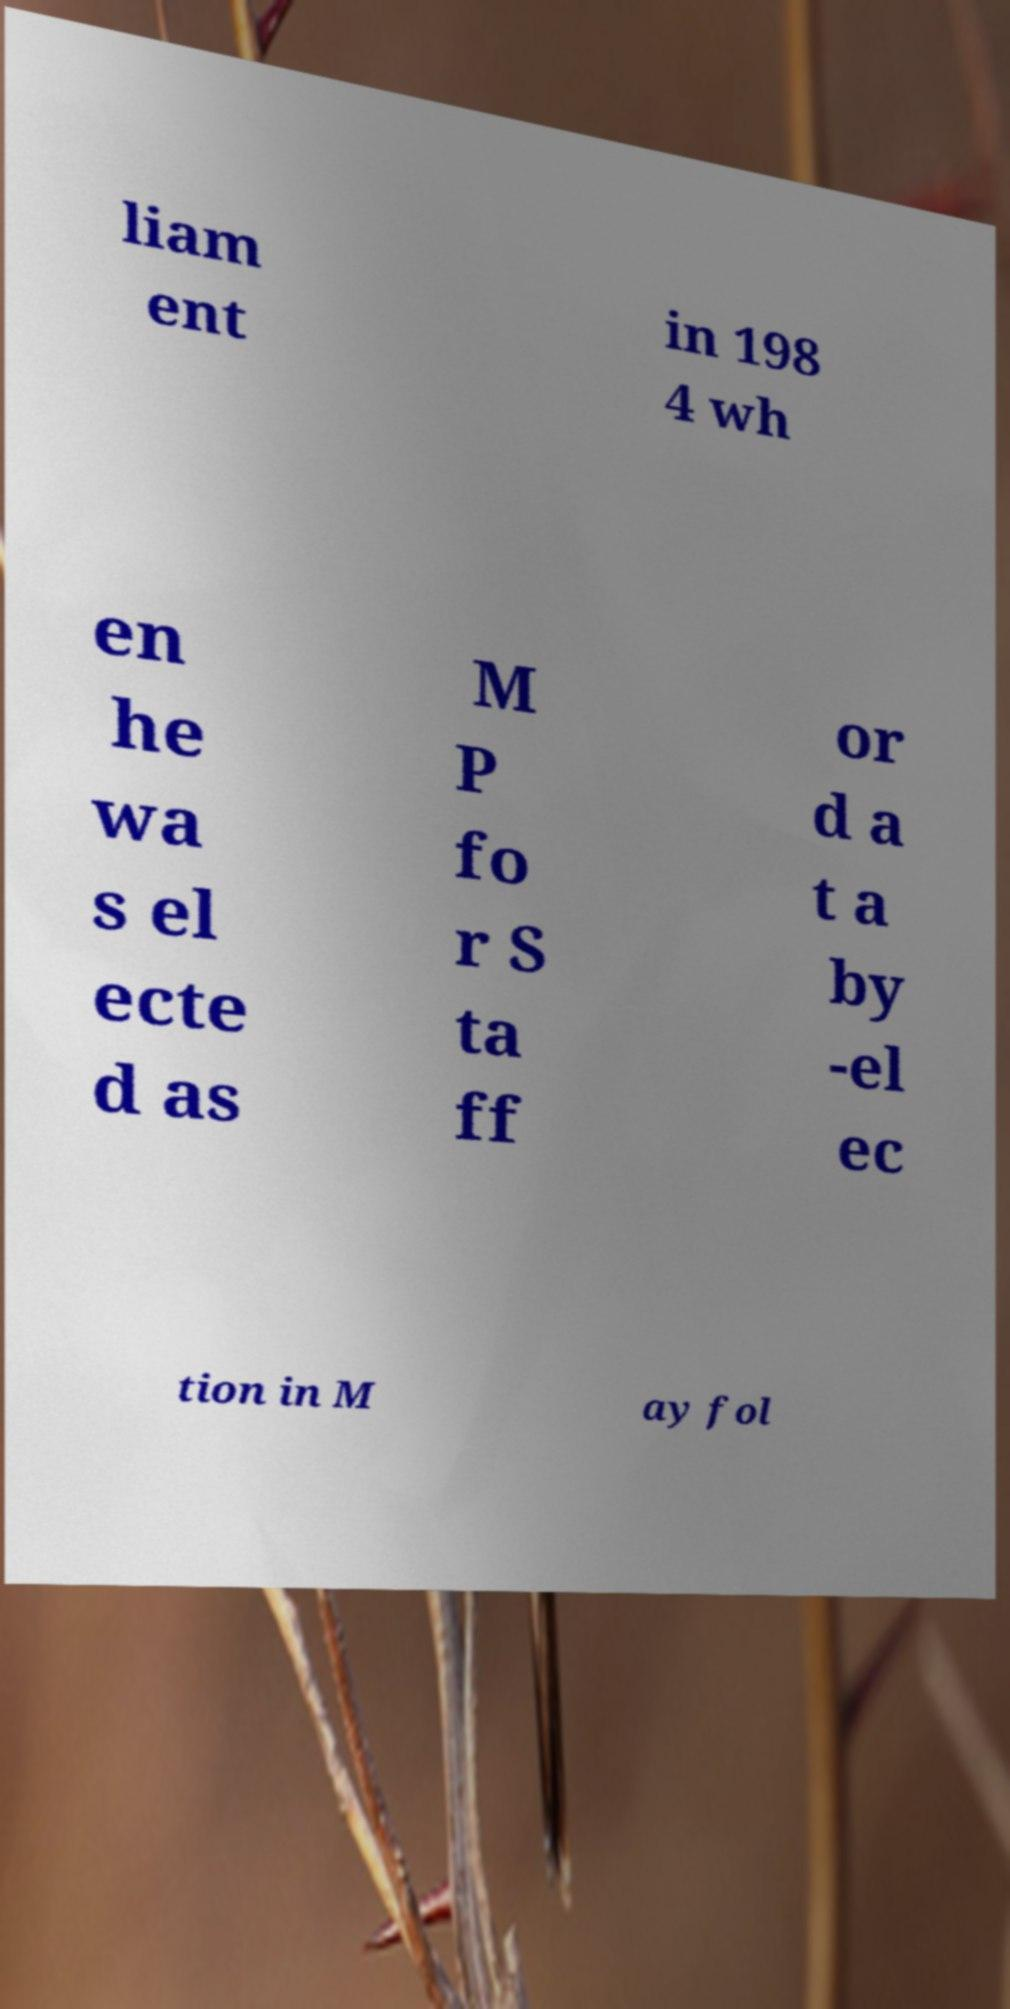Could you assist in decoding the text presented in this image and type it out clearly? liam ent in 198 4 wh en he wa s el ecte d as M P fo r S ta ff or d a t a by -el ec tion in M ay fol 